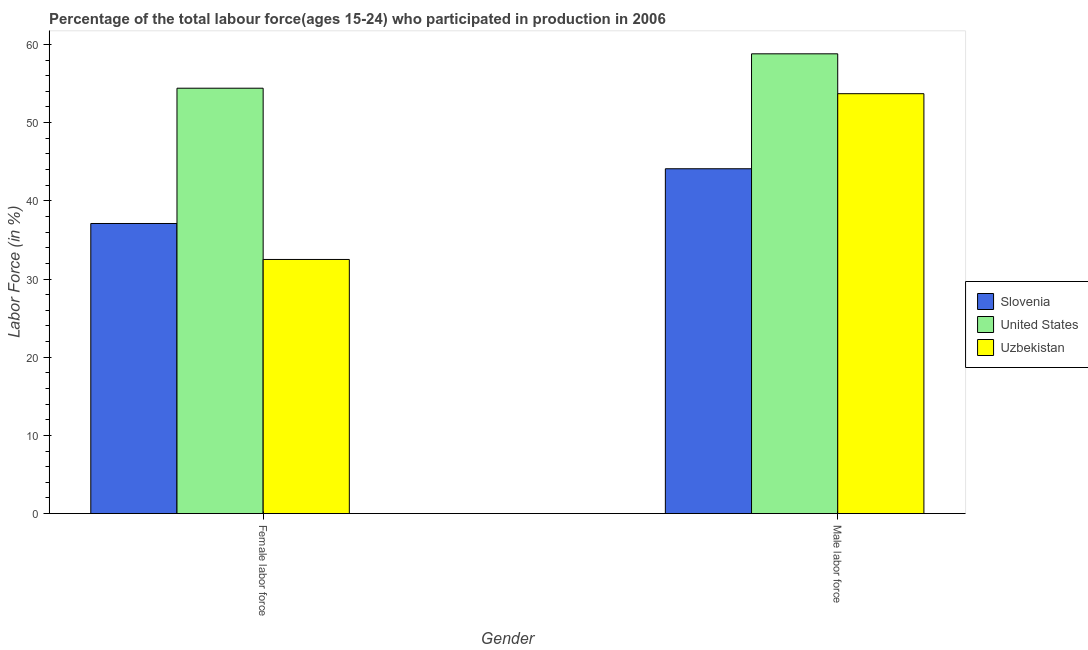How many groups of bars are there?
Ensure brevity in your answer.  2. Are the number of bars per tick equal to the number of legend labels?
Offer a terse response. Yes. How many bars are there on the 2nd tick from the left?
Offer a very short reply. 3. How many bars are there on the 1st tick from the right?
Give a very brief answer. 3. What is the label of the 1st group of bars from the left?
Offer a very short reply. Female labor force. What is the percentage of male labour force in Slovenia?
Provide a short and direct response. 44.1. Across all countries, what is the maximum percentage of male labour force?
Provide a succinct answer. 58.8. Across all countries, what is the minimum percentage of male labour force?
Your answer should be very brief. 44.1. In which country was the percentage of female labor force minimum?
Provide a succinct answer. Uzbekistan. What is the total percentage of female labor force in the graph?
Make the answer very short. 124. What is the difference between the percentage of female labor force in United States and that in Slovenia?
Keep it short and to the point. 17.3. What is the difference between the percentage of male labour force in Uzbekistan and the percentage of female labor force in United States?
Your answer should be compact. -0.7. What is the average percentage of female labor force per country?
Make the answer very short. 41.33. What is the difference between the percentage of male labour force and percentage of female labor force in Slovenia?
Make the answer very short. 7. What is the ratio of the percentage of female labor force in United States to that in Slovenia?
Give a very brief answer. 1.47. Is the percentage of female labor force in United States less than that in Slovenia?
Provide a succinct answer. No. In how many countries, is the percentage of male labour force greater than the average percentage of male labour force taken over all countries?
Make the answer very short. 2. What does the 1st bar from the left in Male labor force represents?
Give a very brief answer. Slovenia. How many bars are there?
Keep it short and to the point. 6. Are the values on the major ticks of Y-axis written in scientific E-notation?
Ensure brevity in your answer.  No. Does the graph contain grids?
Make the answer very short. No. How many legend labels are there?
Provide a succinct answer. 3. How are the legend labels stacked?
Ensure brevity in your answer.  Vertical. What is the title of the graph?
Make the answer very short. Percentage of the total labour force(ages 15-24) who participated in production in 2006. Does "Swaziland" appear as one of the legend labels in the graph?
Give a very brief answer. No. What is the Labor Force (in %) in Slovenia in Female labor force?
Provide a succinct answer. 37.1. What is the Labor Force (in %) of United States in Female labor force?
Your answer should be very brief. 54.4. What is the Labor Force (in %) of Uzbekistan in Female labor force?
Your response must be concise. 32.5. What is the Labor Force (in %) in Slovenia in Male labor force?
Keep it short and to the point. 44.1. What is the Labor Force (in %) in United States in Male labor force?
Your answer should be very brief. 58.8. What is the Labor Force (in %) of Uzbekistan in Male labor force?
Offer a very short reply. 53.7. Across all Gender, what is the maximum Labor Force (in %) of Slovenia?
Provide a succinct answer. 44.1. Across all Gender, what is the maximum Labor Force (in %) of United States?
Your response must be concise. 58.8. Across all Gender, what is the maximum Labor Force (in %) of Uzbekistan?
Make the answer very short. 53.7. Across all Gender, what is the minimum Labor Force (in %) in Slovenia?
Ensure brevity in your answer.  37.1. Across all Gender, what is the minimum Labor Force (in %) in United States?
Offer a very short reply. 54.4. Across all Gender, what is the minimum Labor Force (in %) of Uzbekistan?
Your answer should be very brief. 32.5. What is the total Labor Force (in %) of Slovenia in the graph?
Offer a very short reply. 81.2. What is the total Labor Force (in %) in United States in the graph?
Offer a terse response. 113.2. What is the total Labor Force (in %) of Uzbekistan in the graph?
Give a very brief answer. 86.2. What is the difference between the Labor Force (in %) of Uzbekistan in Female labor force and that in Male labor force?
Offer a terse response. -21.2. What is the difference between the Labor Force (in %) of Slovenia in Female labor force and the Labor Force (in %) of United States in Male labor force?
Make the answer very short. -21.7. What is the difference between the Labor Force (in %) in Slovenia in Female labor force and the Labor Force (in %) in Uzbekistan in Male labor force?
Offer a very short reply. -16.6. What is the difference between the Labor Force (in %) of United States in Female labor force and the Labor Force (in %) of Uzbekistan in Male labor force?
Provide a short and direct response. 0.7. What is the average Labor Force (in %) of Slovenia per Gender?
Your response must be concise. 40.6. What is the average Labor Force (in %) of United States per Gender?
Give a very brief answer. 56.6. What is the average Labor Force (in %) in Uzbekistan per Gender?
Your answer should be compact. 43.1. What is the difference between the Labor Force (in %) in Slovenia and Labor Force (in %) in United States in Female labor force?
Offer a very short reply. -17.3. What is the difference between the Labor Force (in %) of United States and Labor Force (in %) of Uzbekistan in Female labor force?
Keep it short and to the point. 21.9. What is the difference between the Labor Force (in %) of Slovenia and Labor Force (in %) of United States in Male labor force?
Provide a succinct answer. -14.7. What is the difference between the Labor Force (in %) in Slovenia and Labor Force (in %) in Uzbekistan in Male labor force?
Your answer should be compact. -9.6. What is the ratio of the Labor Force (in %) in Slovenia in Female labor force to that in Male labor force?
Your response must be concise. 0.84. What is the ratio of the Labor Force (in %) of United States in Female labor force to that in Male labor force?
Ensure brevity in your answer.  0.93. What is the ratio of the Labor Force (in %) of Uzbekistan in Female labor force to that in Male labor force?
Your answer should be very brief. 0.61. What is the difference between the highest and the second highest Labor Force (in %) of Slovenia?
Offer a very short reply. 7. What is the difference between the highest and the second highest Labor Force (in %) in Uzbekistan?
Your answer should be very brief. 21.2. What is the difference between the highest and the lowest Labor Force (in %) in Slovenia?
Keep it short and to the point. 7. What is the difference between the highest and the lowest Labor Force (in %) of Uzbekistan?
Make the answer very short. 21.2. 